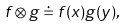Convert formula to latex. <formula><loc_0><loc_0><loc_500><loc_500>f \otimes g \doteq f ( x ) g ( y ) ,</formula> 